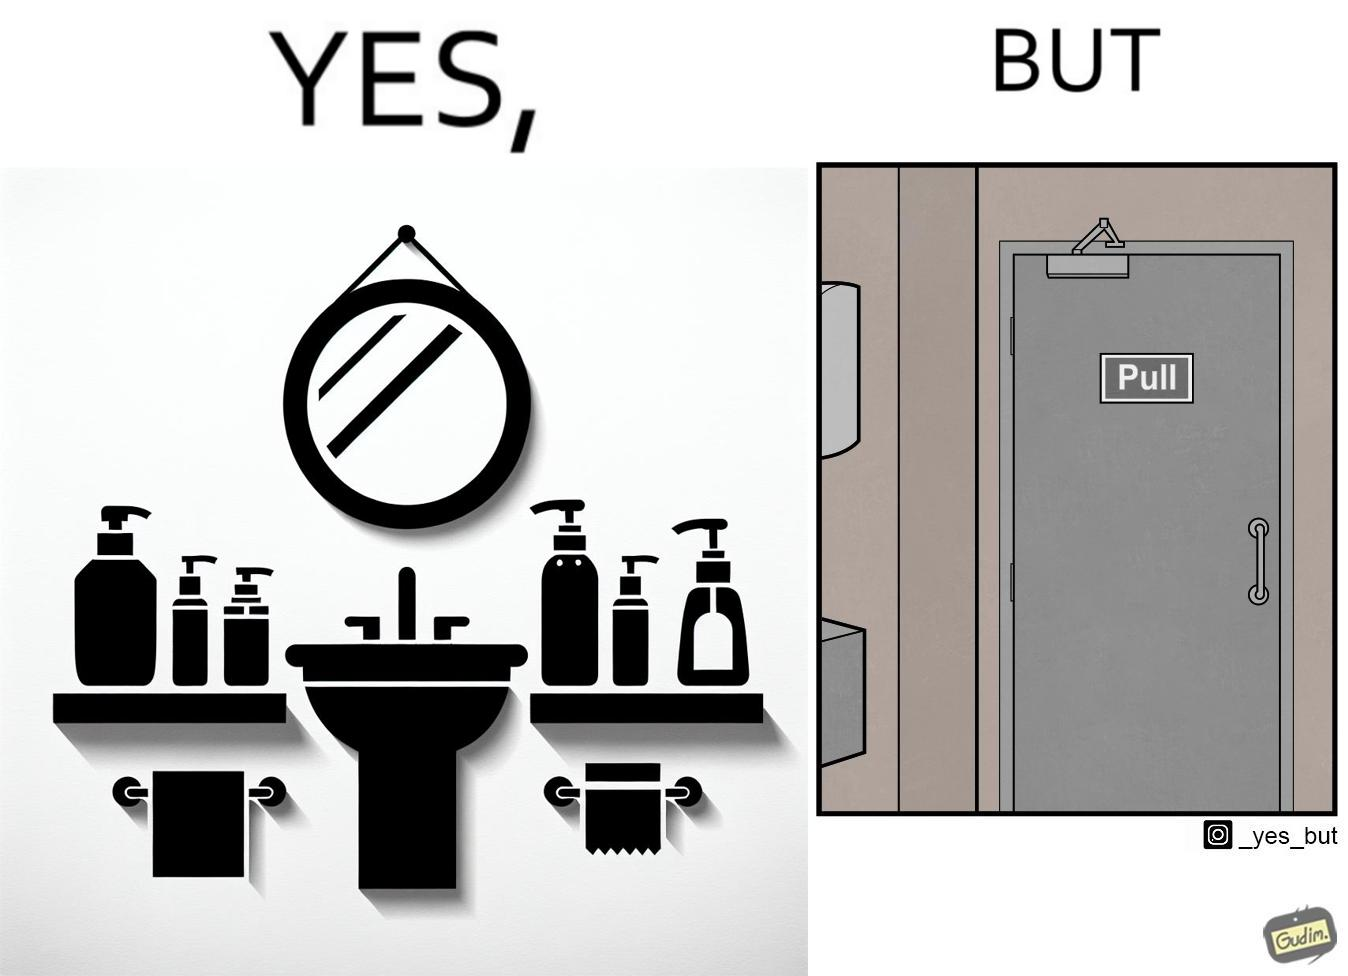Describe the contrast between the left and right parts of this image. In the left part of the image: a basin with different handwashes and paper roll around it to clean hands with a mirror in front In the right part of the image: a door with a pull sign and handle on it 